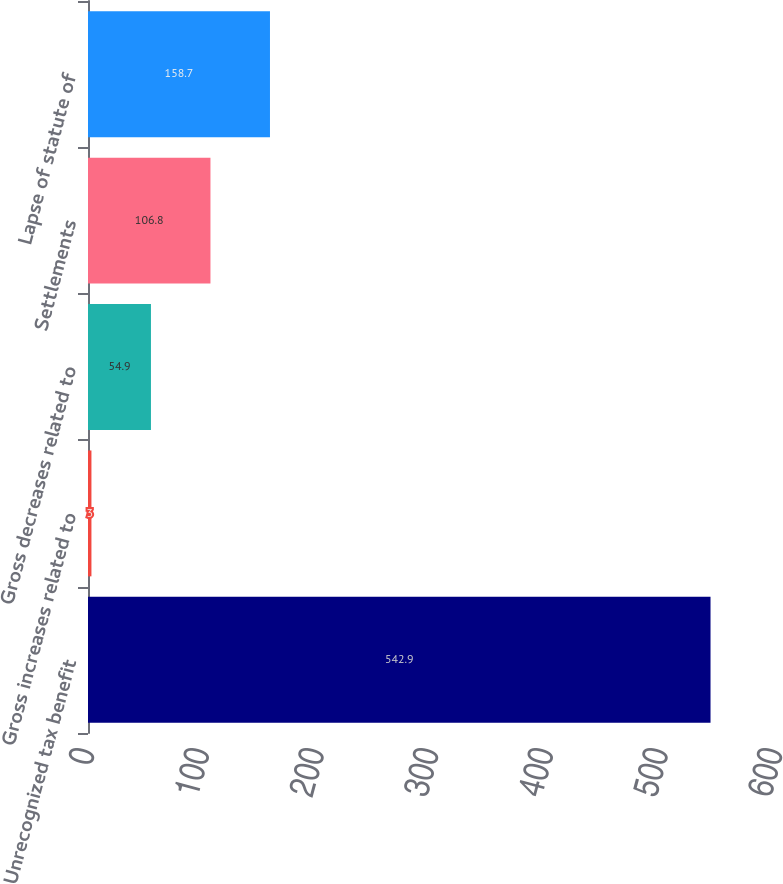Convert chart. <chart><loc_0><loc_0><loc_500><loc_500><bar_chart><fcel>Unrecognized tax benefit<fcel>Gross increases related to<fcel>Gross decreases related to<fcel>Settlements<fcel>Lapse of statute of<nl><fcel>542.9<fcel>3<fcel>54.9<fcel>106.8<fcel>158.7<nl></chart> 